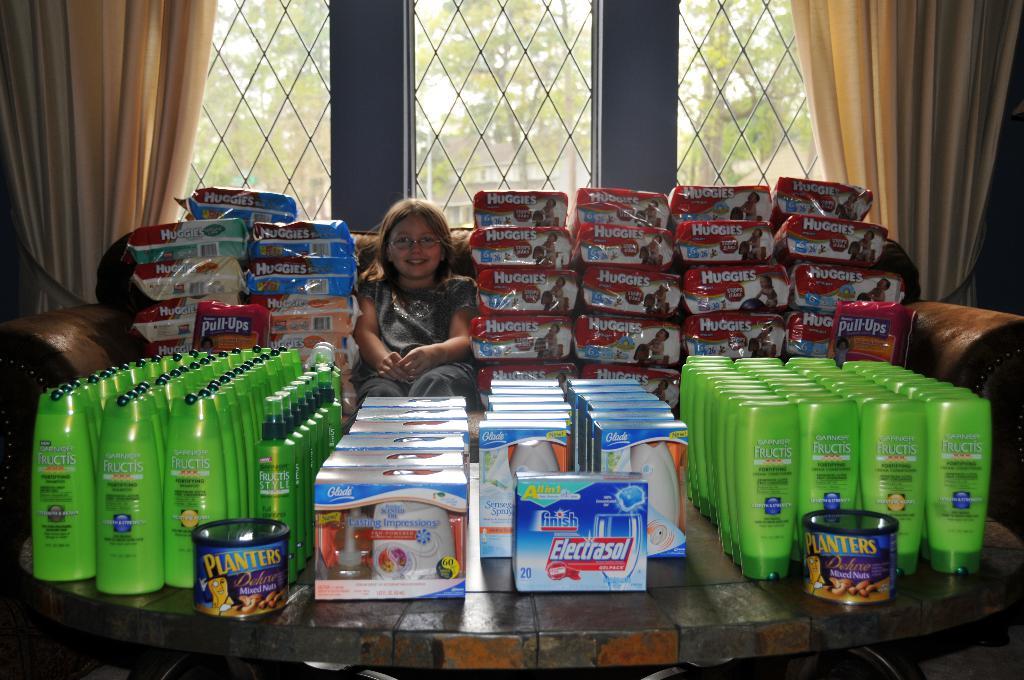What are in the packages?
Give a very brief answer. Huggies. Name the diaper brand?
Make the answer very short. Huggies. 